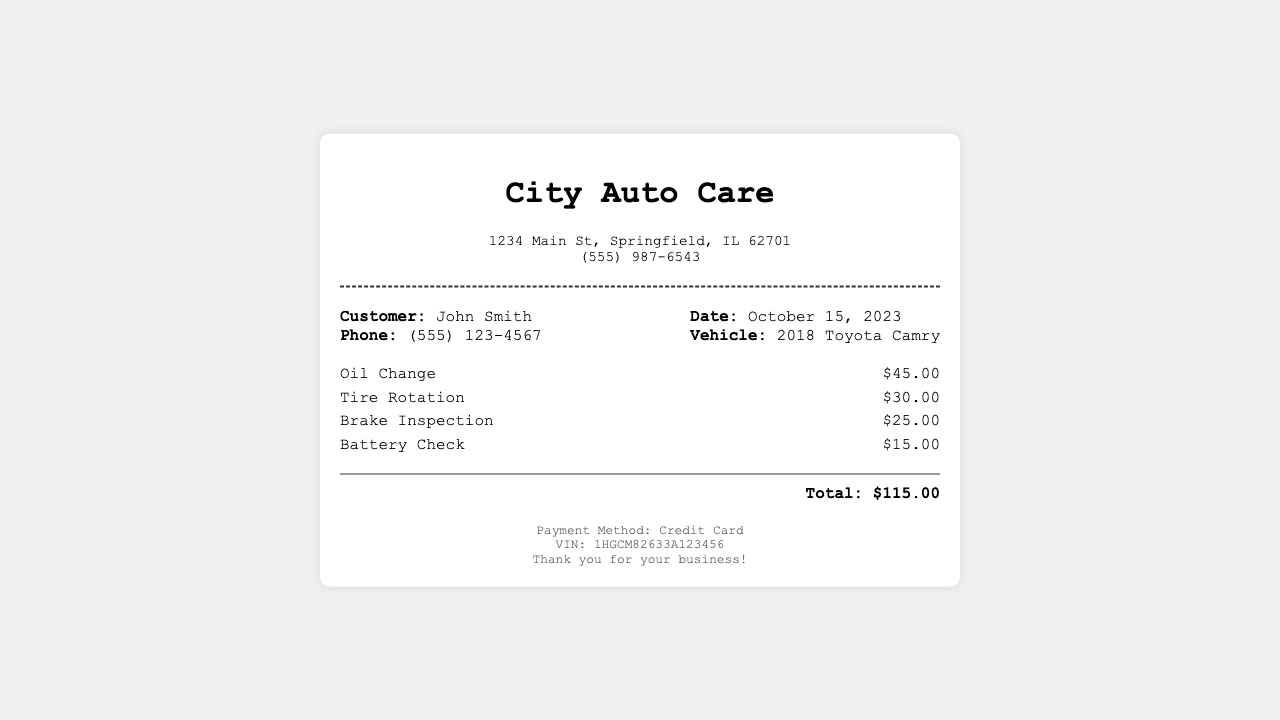What is the name of the business? The name of the business is stated at the top of the receipt as "City Auto Care".
Answer: City Auto Care What is the total amount charged? The total amount charged is displayed at the bottom of the receipt and sums up all service costs.
Answer: $115.00 What services were provided? The receipt lists the services rendered, which includes Oil Change, Tire Rotation, Brake Inspection, and Battery Check.
Answer: Oil Change, Tire Rotation, Brake Inspection, Battery Check When was the service performed? The date of service is mentioned in the customer information section, indicating when the maintenance took place.
Answer: October 15, 2023 How much did the Tire Rotation cost? The cost of the Tire Rotation service is detailed alongside each service listed, showing its specific charge.
Answer: $30.00 What vehicle was serviced? The type of vehicle serviced is indicated in the customer information section as a 2018 Toyota Camry.
Answer: 2018 Toyota Camry What payment method was used? The payment method is specified in the footer section of the receipt.
Answer: Credit Card What is the phone number of the business? The business phone number is listed in the business information section of the receipt.
Answer: (555) 987-6543 